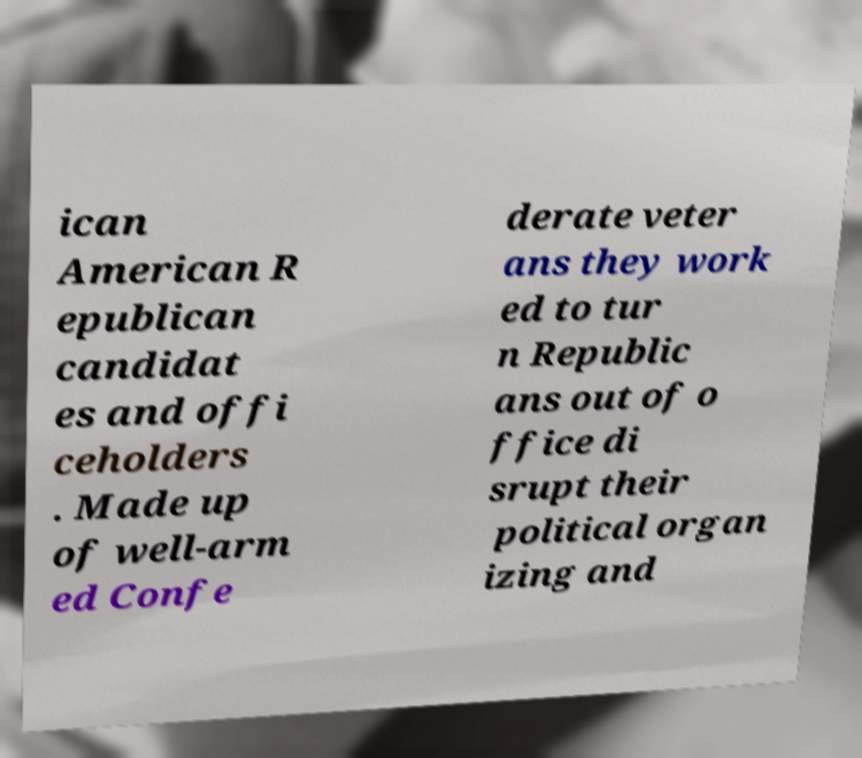Please read and relay the text visible in this image. What does it say? ican American R epublican candidat es and offi ceholders . Made up of well-arm ed Confe derate veter ans they work ed to tur n Republic ans out of o ffice di srupt their political organ izing and 